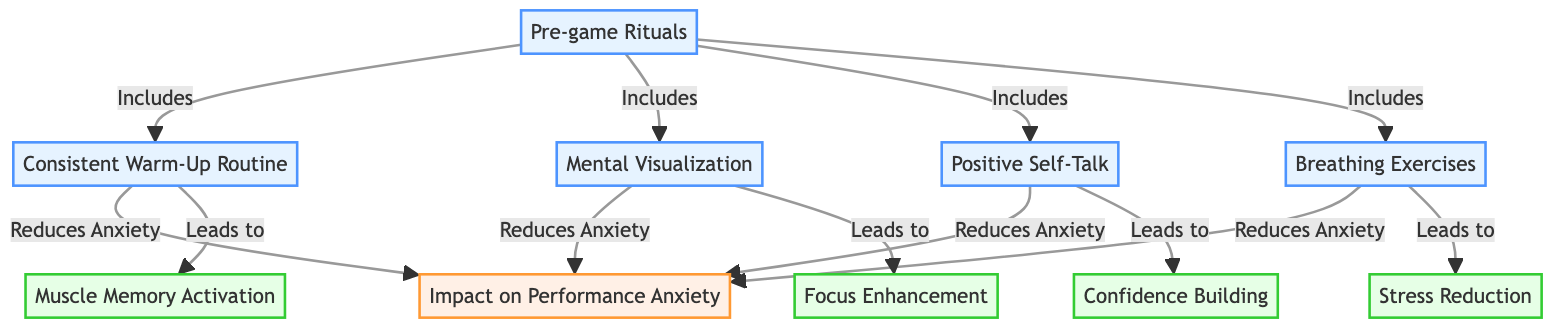What are the four rituals listed in the diagram? The diagram lists four rituals as part of pre-game rituals: Consistent Warm-Up Routine, Mental Visualization, Positive Self-Talk, and Breathing Exercises.
Answer: Consistent Warm-Up Routine, Mental Visualization, Positive Self-Talk, Breathing Exercises How many benefits are mentioned in the diagram? The diagram lists four benefits that result from the pre-game rituals: Muscle Memory Activation, Focus Enhancement, Confidence Building, and Stress Reduction. Counting these yields a total of four benefits.
Answer: 4 Which pre-game ritual specifically leads to confidence building? According to the diagram, Positive Self-Talk specifically leads to confidence building as indicated by the directed edge connecting them.
Answer: Positive Self-Talk How does Mental Visualization impact performance anxiety? The diagram shows that Mental Visualization reduces performance anxiety, as indicated by the arrow leading from Mental Visualization to the Impact on Performance Anxiety node.
Answer: Reduces Anxiety What is the benefit of Breathing Exercises according to the diagram? The diagram indicates that Breathing Exercises lead to Stress Reduction. This can be identified by following the flow from Breathing Exercises to the corresponding benefit node.
Answer: Stress Reduction Which ritual does not have a direct relationship with Muscle Memory Activation? The diagram shows that the Consistent Warm-Up Routine leads to Muscle Memory Activation, while Mental Visualization and Breathing Exercises do not have a direct path to this benefit, as they lead to Focus Enhancement and Stress Reduction, respectively. Therefore, both Mental Visualization and Breathing Exercises do not lead to Muscle Memory Activation.
Answer: Mental Visualization, Breathing Exercises What is the primary focus of the diagram? The diagram focuses on the relationship between pre-game rituals and their impact on performance anxiety, detailing the specific rituals and their psychological benefits.
Answer: Pre-game Rituals and Their Impact on Performance Anxiety How many nodes are there in total? Counting the nodes in the diagram, we have one node for pre-game rituals, four ritual nodes, one impact node, and four benefit nodes. This results in a total of ten nodes in the diagram.
Answer: 10 